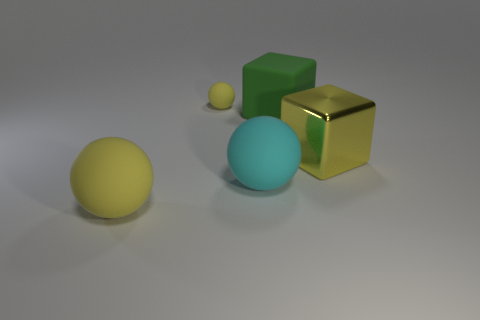Is the size of the yellow metallic thing the same as the cyan matte ball?
Give a very brief answer. Yes. There is a ball that is both in front of the large shiny object and on the left side of the large cyan ball; what is its color?
Keep it short and to the point. Yellow. How many cyan objects are the same material as the green block?
Offer a terse response. 1. What number of large matte things are there?
Keep it short and to the point. 3. Is the size of the yellow block the same as the yellow ball behind the yellow cube?
Make the answer very short. No. What material is the big yellow thing that is left of the large thing behind the yellow cube?
Provide a short and direct response. Rubber. There is a yellow matte object that is behind the big rubber ball right of the large yellow object on the left side of the cyan sphere; what size is it?
Provide a short and direct response. Small. Do the large green matte object and the yellow matte thing that is in front of the big green rubber cube have the same shape?
Keep it short and to the point. No. What is the material of the cyan ball?
Your response must be concise. Rubber. How many shiny objects are small yellow cylinders or big balls?
Ensure brevity in your answer.  0. 